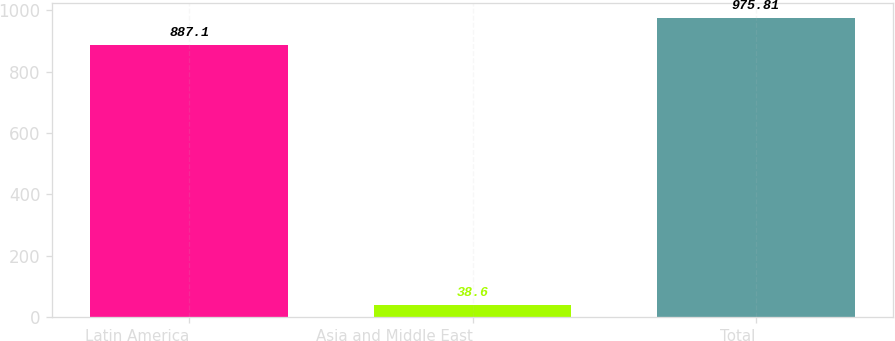Convert chart. <chart><loc_0><loc_0><loc_500><loc_500><bar_chart><fcel>Latin America<fcel>Asia and Middle East<fcel>Total<nl><fcel>887.1<fcel>38.6<fcel>975.81<nl></chart> 